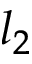Convert formula to latex. <formula><loc_0><loc_0><loc_500><loc_500>l _ { 2 }</formula> 